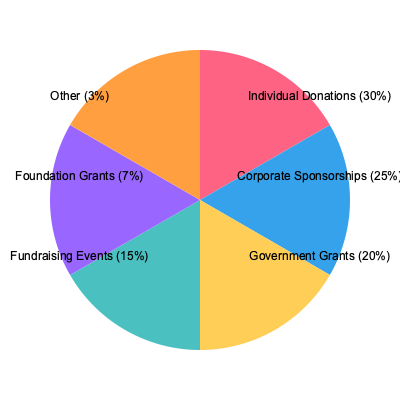Based on the pie chart showing the distribution of funding sources for non-profit organizations, what percentage of total funding comes from a combination of government grants and corporate sponsorships? How might this funding mix impact the organization's strategies and priorities? To answer this question, we need to follow these steps:

1. Identify the percentages for government grants and corporate sponsorships from the pie chart:
   - Government Grants: 20%
   - Corporate Sponsorships: 25%

2. Add these two percentages together:
   $20\% + 25\% = 45\%$

3. Interpret the impact of this funding mix:
   a) Diversification: Having 45% of funding from two major sources provides some stability, but also creates dependence on these sources.
   
   b) Accountability: Government grants often come with strict reporting requirements and specific program goals, which may influence the organization's focus and operations.
   
   c) Corporate influence: With 25% from corporate sponsorships, the organization may need to balance corporate interests with its mission.
   
   d) Sustainability: The organization might want to develop strategies to maintain and grow these funding sources while also exploring ways to increase other funding streams for long-term sustainability.
   
   e) Program alignment: The organization may need to align some of its programs with government and corporate priorities to maintain this level of funding.
   
   f) Capacity building: Managing government grants and corporate sponsorships often requires dedicated staff and systems, which the organization would need to invest in.
Answer: 45%; impacts include increased accountability, potential corporate influence, need for strategic alignment, and investment in capacity to manage these funding sources. 